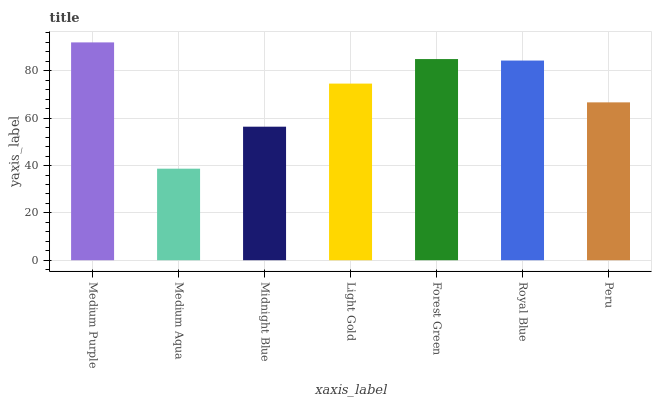Is Medium Aqua the minimum?
Answer yes or no. Yes. Is Medium Purple the maximum?
Answer yes or no. Yes. Is Midnight Blue the minimum?
Answer yes or no. No. Is Midnight Blue the maximum?
Answer yes or no. No. Is Midnight Blue greater than Medium Aqua?
Answer yes or no. Yes. Is Medium Aqua less than Midnight Blue?
Answer yes or no. Yes. Is Medium Aqua greater than Midnight Blue?
Answer yes or no. No. Is Midnight Blue less than Medium Aqua?
Answer yes or no. No. Is Light Gold the high median?
Answer yes or no. Yes. Is Light Gold the low median?
Answer yes or no. Yes. Is Peru the high median?
Answer yes or no. No. Is Midnight Blue the low median?
Answer yes or no. No. 